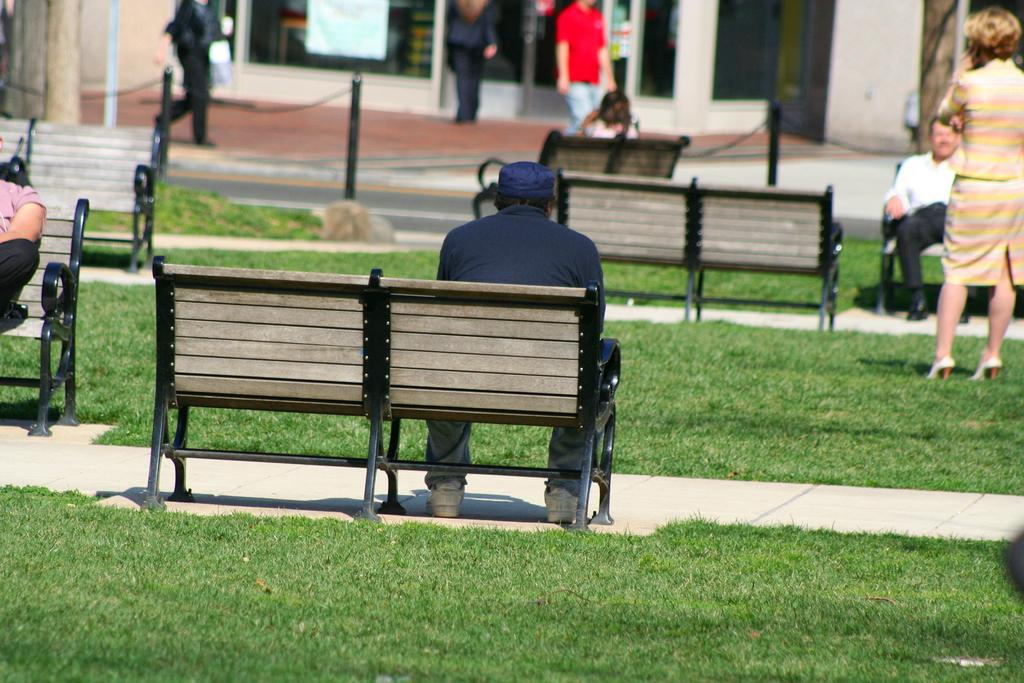What are the people in the image doing? Some people are sitting on benches, some are walking, and some are standing. Can you describe the actions of the people in the image? The people sitting on benches are likely resting, while those walking are moving from one place to another, and the people standing may be waiting or observing something. What type of secretary can be seen working in the image? There is no secretary present in the image; it only shows people sitting, walking, and standing. 